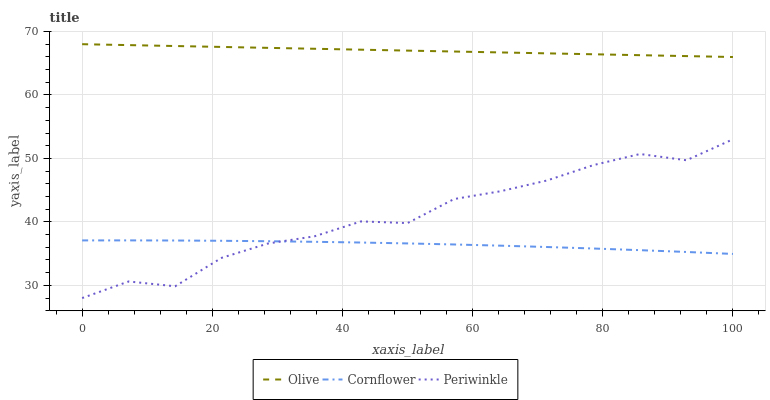Does Cornflower have the minimum area under the curve?
Answer yes or no. Yes. Does Olive have the maximum area under the curve?
Answer yes or no. Yes. Does Periwinkle have the minimum area under the curve?
Answer yes or no. No. Does Periwinkle have the maximum area under the curve?
Answer yes or no. No. Is Olive the smoothest?
Answer yes or no. Yes. Is Periwinkle the roughest?
Answer yes or no. Yes. Is Cornflower the smoothest?
Answer yes or no. No. Is Cornflower the roughest?
Answer yes or no. No. Does Cornflower have the lowest value?
Answer yes or no. No. Does Periwinkle have the highest value?
Answer yes or no. No. Is Cornflower less than Olive?
Answer yes or no. Yes. Is Olive greater than Periwinkle?
Answer yes or no. Yes. Does Cornflower intersect Olive?
Answer yes or no. No. 